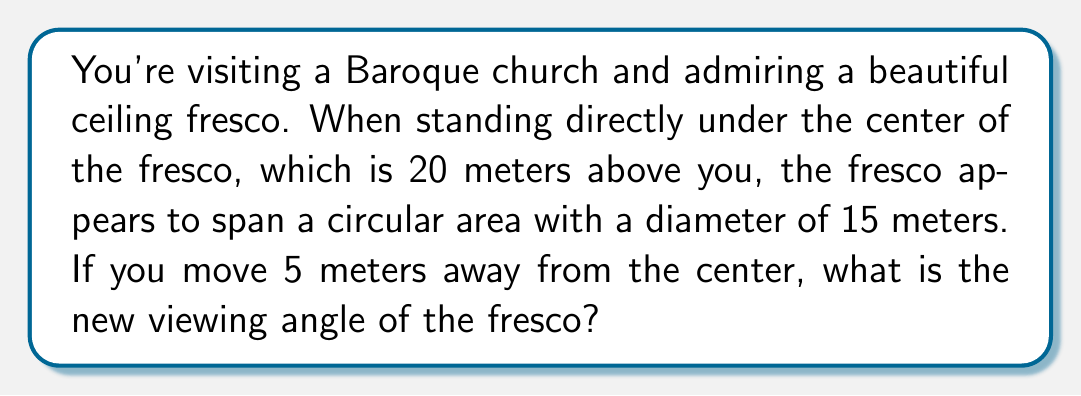Could you help me with this problem? Let's approach this step-by-step:

1) First, we need to understand what the viewing angle is. It's the angle between the lines of sight to the edges of the fresco.

2) When standing directly under the fresco, we can calculate half of the viewing angle using the tangent function:

   $$\tan(\theta/2) = \frac{7.5}{20}$$

   Where 7.5 is half the diameter of the fresco, and 20 is the height.

3) Solving for $\theta$:

   $$\theta = 2 \cdot \arctan(\frac{7.5}{20}) \approx 41.11°$$

4) Now, when we move 5 meters away, we form a right triangle. Let's call the new viewing angle $\phi$. We can split this triangle into two right triangles:

   [asy]
   import geometry;
   
   size(200);
   
   pair A = (0,0), B = (5,0), C = (0,20);
   pair D = (-7.5,20), E = (12.5,20);
   
   draw(A--B--C--cycle);
   draw(B--D);
   draw(B--E);
   
   label("5m", (A+B)/2, S);
   label("20m", (A+C)/2, W);
   label("7.5m", (C+D)/2, N);
   label("12.5m", (C+E)/2, N);
   label("$\phi$", B, SE);
   
   [/asy]

5) For the left triangle:

   $$\tan(\phi_1) = \frac{7.5}{20}$$

6) For the right triangle:

   $$\tan(\phi_2) = \frac{12.5}{20}$$

7) The total viewing angle $\phi$ is the sum of these two angles:

   $$\phi = \arctan(\frac{7.5}{20}) + \arctan(\frac{12.5}{20})$$

8) Calculating this:

   $$\phi \approx 20.56° + 32.01° = 52.57°$$
Answer: $52.57°$ 